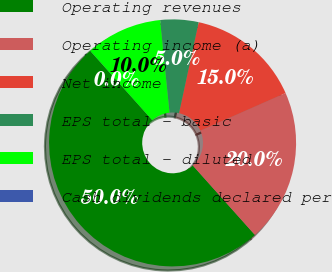Convert chart. <chart><loc_0><loc_0><loc_500><loc_500><pie_chart><fcel>Operating revenues<fcel>Operating income (a)<fcel>Net income<fcel>EPS total - basic<fcel>EPS total - diluted<fcel>Cash dividends declared per<nl><fcel>49.99%<fcel>20.0%<fcel>15.0%<fcel>5.0%<fcel>10.0%<fcel>0.01%<nl></chart> 